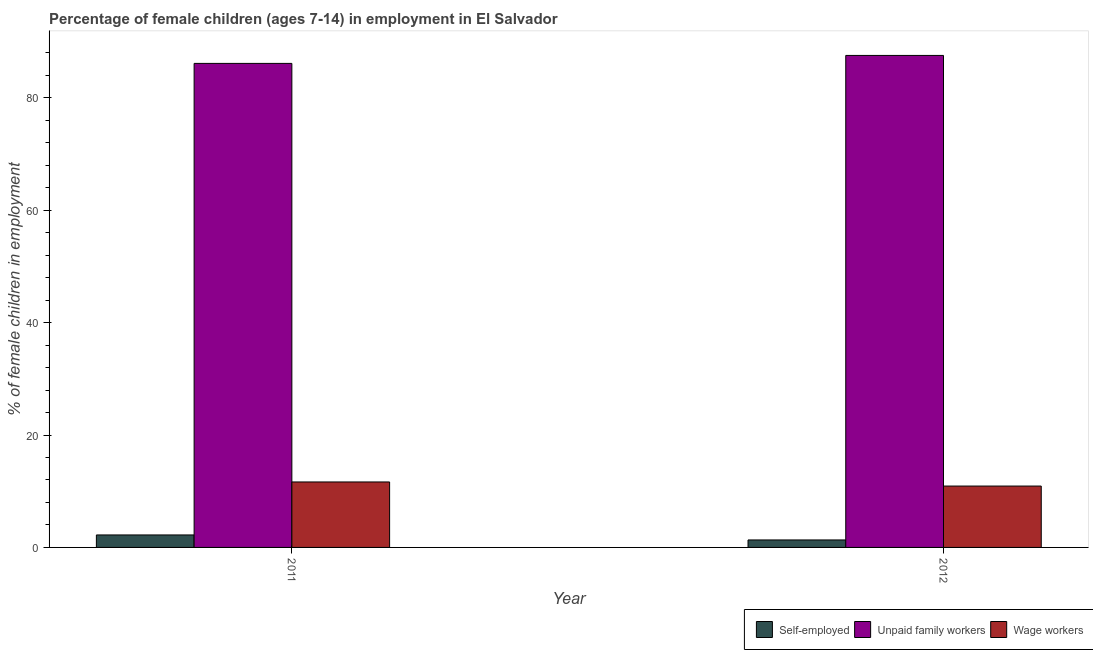How many different coloured bars are there?
Ensure brevity in your answer.  3. Are the number of bars on each tick of the X-axis equal?
Provide a succinct answer. Yes. How many bars are there on the 1st tick from the left?
Your response must be concise. 3. What is the label of the 1st group of bars from the left?
Your answer should be very brief. 2011. In how many cases, is the number of bars for a given year not equal to the number of legend labels?
Offer a very short reply. 0. What is the percentage of children employed as unpaid family workers in 2012?
Your answer should be very brief. 87.55. Across all years, what is the maximum percentage of self employed children?
Keep it short and to the point. 2.22. Across all years, what is the minimum percentage of self employed children?
Provide a short and direct response. 1.33. What is the total percentage of children employed as unpaid family workers in the graph?
Keep it short and to the point. 173.68. What is the difference between the percentage of self employed children in 2011 and that in 2012?
Provide a short and direct response. 0.89. What is the difference between the percentage of children employed as unpaid family workers in 2011 and the percentage of self employed children in 2012?
Your answer should be compact. -1.42. What is the average percentage of children employed as wage workers per year?
Make the answer very short. 11.29. What is the ratio of the percentage of children employed as unpaid family workers in 2011 to that in 2012?
Ensure brevity in your answer.  0.98. In how many years, is the percentage of self employed children greater than the average percentage of self employed children taken over all years?
Your answer should be very brief. 1. What does the 1st bar from the left in 2012 represents?
Offer a terse response. Self-employed. What does the 1st bar from the right in 2011 represents?
Ensure brevity in your answer.  Wage workers. Is it the case that in every year, the sum of the percentage of self employed children and percentage of children employed as unpaid family workers is greater than the percentage of children employed as wage workers?
Your answer should be very brief. Yes. How many bars are there?
Keep it short and to the point. 6. Are all the bars in the graph horizontal?
Offer a very short reply. No. Does the graph contain any zero values?
Offer a terse response. No. Does the graph contain grids?
Your answer should be compact. No. Where does the legend appear in the graph?
Your answer should be very brief. Bottom right. How many legend labels are there?
Make the answer very short. 3. What is the title of the graph?
Provide a succinct answer. Percentage of female children (ages 7-14) in employment in El Salvador. What is the label or title of the Y-axis?
Your response must be concise. % of female children in employment. What is the % of female children in employment of Self-employed in 2011?
Make the answer very short. 2.22. What is the % of female children in employment in Unpaid family workers in 2011?
Give a very brief answer. 86.13. What is the % of female children in employment of Wage workers in 2011?
Your answer should be compact. 11.65. What is the % of female children in employment of Self-employed in 2012?
Ensure brevity in your answer.  1.33. What is the % of female children in employment in Unpaid family workers in 2012?
Give a very brief answer. 87.55. What is the % of female children in employment of Wage workers in 2012?
Offer a very short reply. 10.92. Across all years, what is the maximum % of female children in employment of Self-employed?
Your answer should be very brief. 2.22. Across all years, what is the maximum % of female children in employment in Unpaid family workers?
Offer a very short reply. 87.55. Across all years, what is the maximum % of female children in employment of Wage workers?
Keep it short and to the point. 11.65. Across all years, what is the minimum % of female children in employment of Self-employed?
Offer a terse response. 1.33. Across all years, what is the minimum % of female children in employment of Unpaid family workers?
Offer a very short reply. 86.13. Across all years, what is the minimum % of female children in employment in Wage workers?
Give a very brief answer. 10.92. What is the total % of female children in employment in Self-employed in the graph?
Provide a short and direct response. 3.55. What is the total % of female children in employment in Unpaid family workers in the graph?
Offer a very short reply. 173.68. What is the total % of female children in employment of Wage workers in the graph?
Provide a short and direct response. 22.57. What is the difference between the % of female children in employment of Self-employed in 2011 and that in 2012?
Provide a succinct answer. 0.89. What is the difference between the % of female children in employment in Unpaid family workers in 2011 and that in 2012?
Your response must be concise. -1.42. What is the difference between the % of female children in employment in Wage workers in 2011 and that in 2012?
Keep it short and to the point. 0.73. What is the difference between the % of female children in employment in Self-employed in 2011 and the % of female children in employment in Unpaid family workers in 2012?
Your answer should be compact. -85.33. What is the difference between the % of female children in employment in Unpaid family workers in 2011 and the % of female children in employment in Wage workers in 2012?
Keep it short and to the point. 75.21. What is the average % of female children in employment of Self-employed per year?
Your response must be concise. 1.77. What is the average % of female children in employment in Unpaid family workers per year?
Your answer should be very brief. 86.84. What is the average % of female children in employment in Wage workers per year?
Offer a very short reply. 11.29. In the year 2011, what is the difference between the % of female children in employment of Self-employed and % of female children in employment of Unpaid family workers?
Keep it short and to the point. -83.91. In the year 2011, what is the difference between the % of female children in employment of Self-employed and % of female children in employment of Wage workers?
Your answer should be compact. -9.43. In the year 2011, what is the difference between the % of female children in employment in Unpaid family workers and % of female children in employment in Wage workers?
Provide a short and direct response. 74.48. In the year 2012, what is the difference between the % of female children in employment in Self-employed and % of female children in employment in Unpaid family workers?
Ensure brevity in your answer.  -86.22. In the year 2012, what is the difference between the % of female children in employment of Self-employed and % of female children in employment of Wage workers?
Offer a terse response. -9.59. In the year 2012, what is the difference between the % of female children in employment in Unpaid family workers and % of female children in employment in Wage workers?
Ensure brevity in your answer.  76.63. What is the ratio of the % of female children in employment in Self-employed in 2011 to that in 2012?
Give a very brief answer. 1.67. What is the ratio of the % of female children in employment in Unpaid family workers in 2011 to that in 2012?
Provide a succinct answer. 0.98. What is the ratio of the % of female children in employment in Wage workers in 2011 to that in 2012?
Make the answer very short. 1.07. What is the difference between the highest and the second highest % of female children in employment in Self-employed?
Your response must be concise. 0.89. What is the difference between the highest and the second highest % of female children in employment of Unpaid family workers?
Provide a short and direct response. 1.42. What is the difference between the highest and the second highest % of female children in employment of Wage workers?
Provide a succinct answer. 0.73. What is the difference between the highest and the lowest % of female children in employment in Self-employed?
Offer a terse response. 0.89. What is the difference between the highest and the lowest % of female children in employment of Unpaid family workers?
Make the answer very short. 1.42. What is the difference between the highest and the lowest % of female children in employment in Wage workers?
Give a very brief answer. 0.73. 